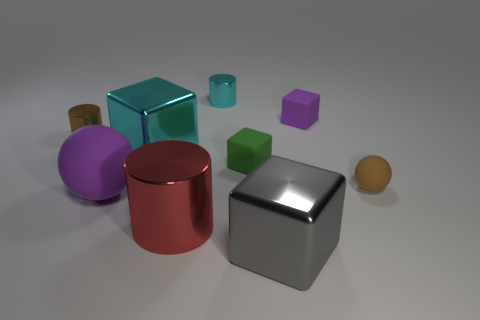Is the number of small brown objects that are right of the big matte thing greater than the number of purple blocks that are on the left side of the big cyan object?
Keep it short and to the point. Yes. Does the small shiny cylinder in front of the cyan cylinder have the same color as the big metal cube right of the tiny green block?
Your answer should be very brief. No. What shape is the cyan object that is the same size as the red thing?
Offer a very short reply. Cube. Is there a large rubber object that has the same shape as the big red shiny thing?
Give a very brief answer. No. Is the material of the block that is in front of the big red thing the same as the small brown object to the left of the green object?
Offer a very short reply. Yes. There is a shiny thing that is the same color as the small sphere; what is its shape?
Keep it short and to the point. Cylinder. What number of large blocks have the same material as the big purple sphere?
Your response must be concise. 0. The large metal cylinder is what color?
Offer a terse response. Red. There is a small rubber object left of the small purple block; is it the same shape as the brown object on the right side of the red shiny thing?
Your answer should be very brief. No. What is the color of the cylinder in front of the small brown cylinder?
Make the answer very short. Red. 